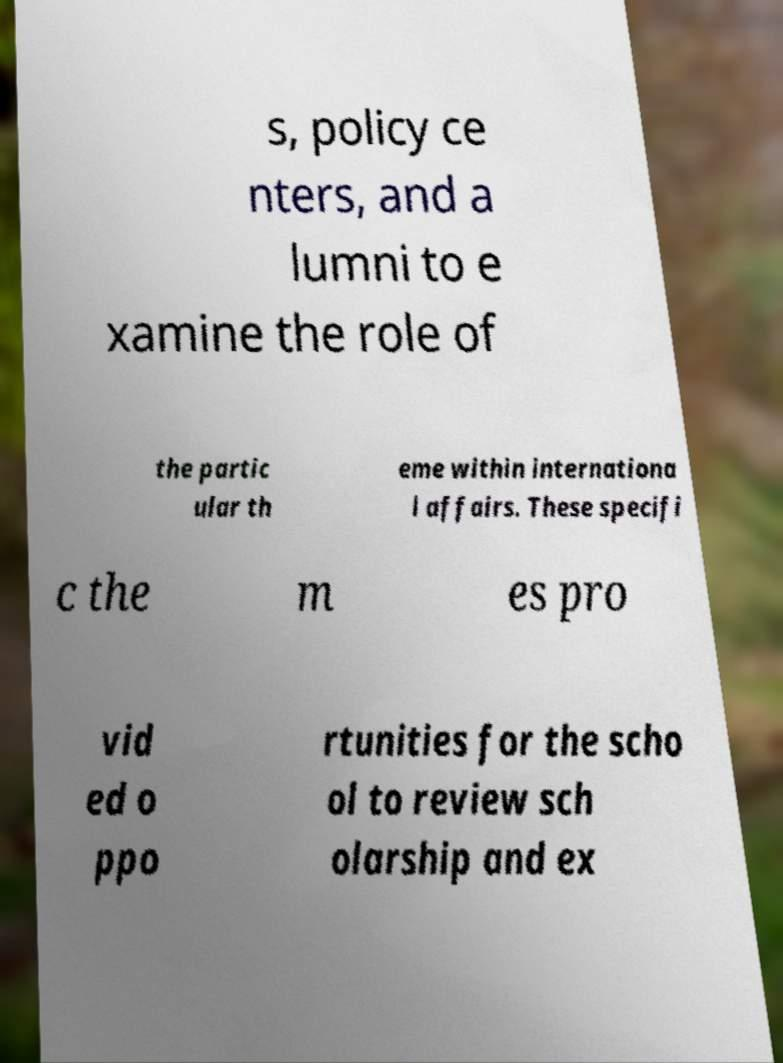Can you read and provide the text displayed in the image?This photo seems to have some interesting text. Can you extract and type it out for me? s, policy ce nters, and a lumni to e xamine the role of the partic ular th eme within internationa l affairs. These specifi c the m es pro vid ed o ppo rtunities for the scho ol to review sch olarship and ex 